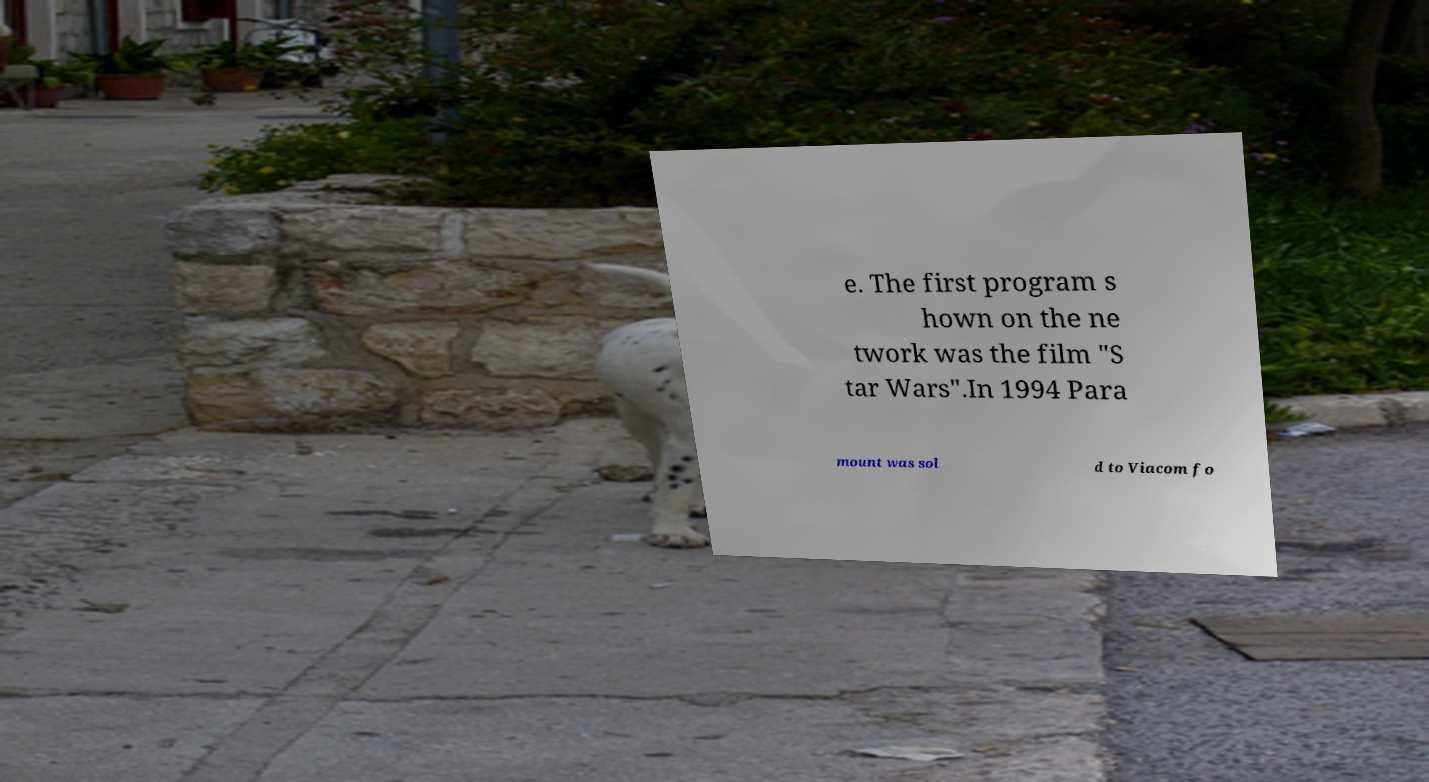Could you assist in decoding the text presented in this image and type it out clearly? e. The first program s hown on the ne twork was the film "S tar Wars".In 1994 Para mount was sol d to Viacom fo 